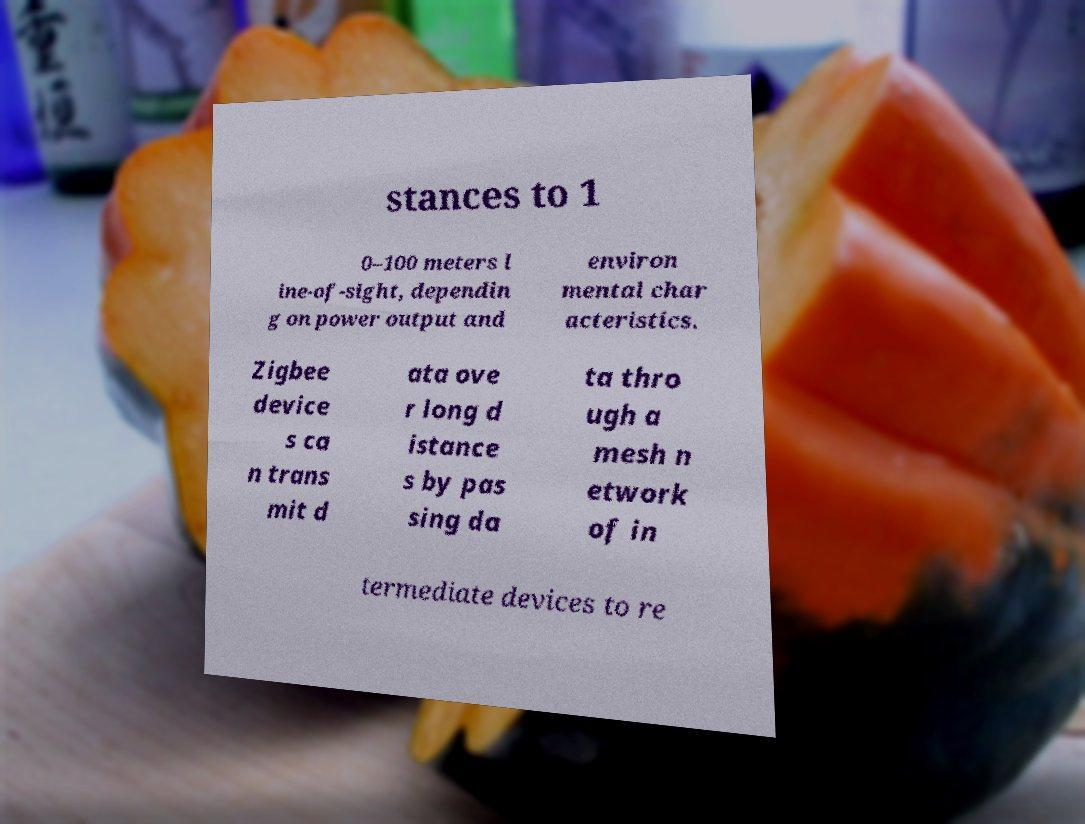I need the written content from this picture converted into text. Can you do that? stances to 1 0–100 meters l ine-of-sight, dependin g on power output and environ mental char acteristics. Zigbee device s ca n trans mit d ata ove r long d istance s by pas sing da ta thro ugh a mesh n etwork of in termediate devices to re 